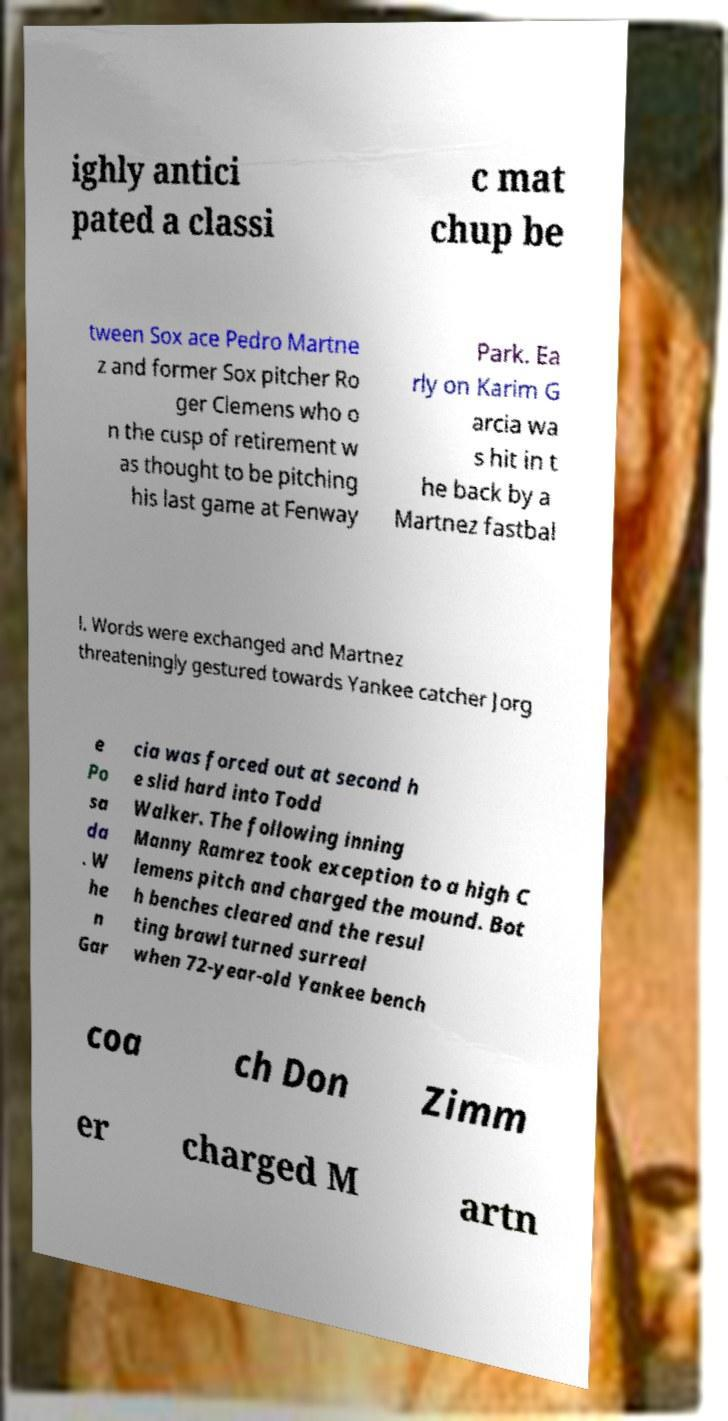Please read and relay the text visible in this image. What does it say? ighly antici pated a classi c mat chup be tween Sox ace Pedro Martne z and former Sox pitcher Ro ger Clemens who o n the cusp of retirement w as thought to be pitching his last game at Fenway Park. Ea rly on Karim G arcia wa s hit in t he back by a Martnez fastbal l. Words were exchanged and Martnez threateningly gestured towards Yankee catcher Jorg e Po sa da . W he n Gar cia was forced out at second h e slid hard into Todd Walker. The following inning Manny Ramrez took exception to a high C lemens pitch and charged the mound. Bot h benches cleared and the resul ting brawl turned surreal when 72-year-old Yankee bench coa ch Don Zimm er charged M artn 